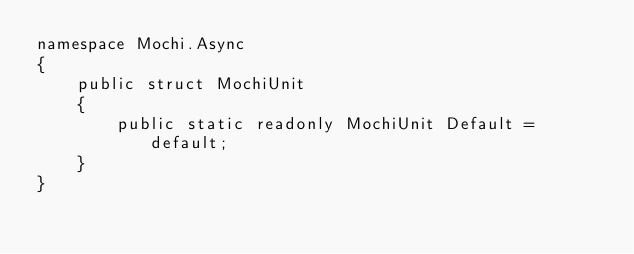<code> <loc_0><loc_0><loc_500><loc_500><_C#_>namespace Mochi.Async
{
    public struct MochiUnit
    {
        public static readonly MochiUnit Default = default;
    }
}
</code> 